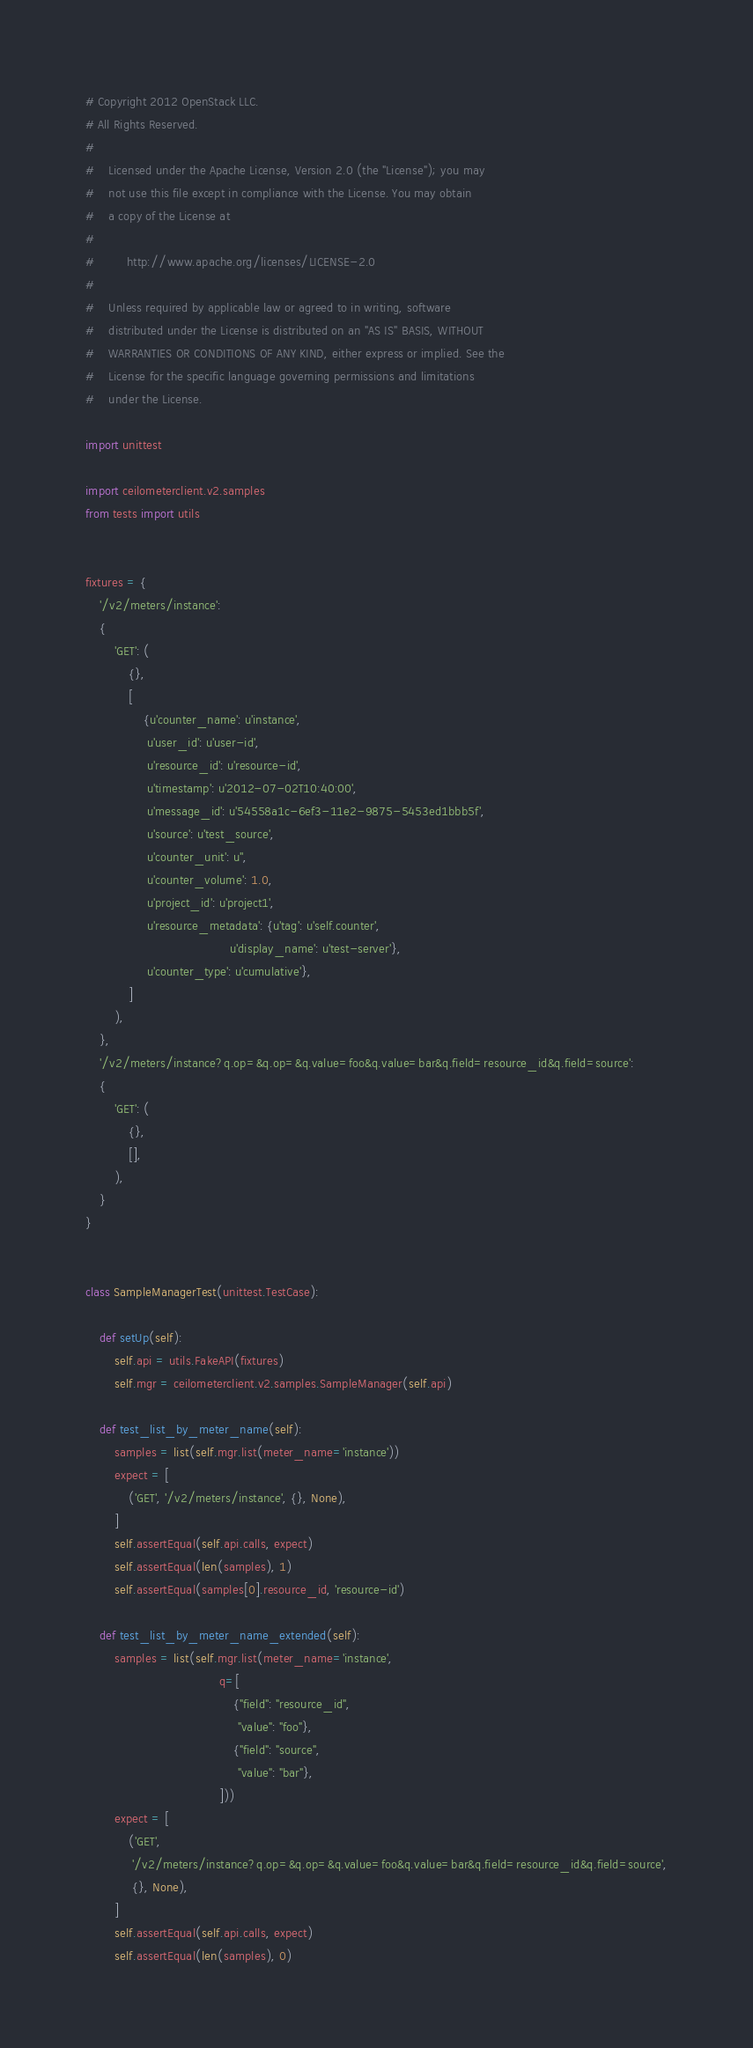Convert code to text. <code><loc_0><loc_0><loc_500><loc_500><_Python_># Copyright 2012 OpenStack LLC.
# All Rights Reserved.
#
#    Licensed under the Apache License, Version 2.0 (the "License"); you may
#    not use this file except in compliance with the License. You may obtain
#    a copy of the License at
#
#         http://www.apache.org/licenses/LICENSE-2.0
#
#    Unless required by applicable law or agreed to in writing, software
#    distributed under the License is distributed on an "AS IS" BASIS, WITHOUT
#    WARRANTIES OR CONDITIONS OF ANY KIND, either express or implied. See the
#    License for the specific language governing permissions and limitations
#    under the License.

import unittest

import ceilometerclient.v2.samples
from tests import utils


fixtures = {
    '/v2/meters/instance':
    {
        'GET': (
            {},
            [
                {u'counter_name': u'instance',
                 u'user_id': u'user-id',
                 u'resource_id': u'resource-id',
                 u'timestamp': u'2012-07-02T10:40:00',
                 u'message_id': u'54558a1c-6ef3-11e2-9875-5453ed1bbb5f',
                 u'source': u'test_source',
                 u'counter_unit': u'',
                 u'counter_volume': 1.0,
                 u'project_id': u'project1',
                 u'resource_metadata': {u'tag': u'self.counter',
                                        u'display_name': u'test-server'},
                 u'counter_type': u'cumulative'},
            ]
        ),
    },
    '/v2/meters/instance?q.op=&q.op=&q.value=foo&q.value=bar&q.field=resource_id&q.field=source':
    {
        'GET': (
            {},
            [],
        ),
    }
}


class SampleManagerTest(unittest.TestCase):

    def setUp(self):
        self.api = utils.FakeAPI(fixtures)
        self.mgr = ceilometerclient.v2.samples.SampleManager(self.api)

    def test_list_by_meter_name(self):
        samples = list(self.mgr.list(meter_name='instance'))
        expect = [
            ('GET', '/v2/meters/instance', {}, None),
        ]
        self.assertEqual(self.api.calls, expect)
        self.assertEqual(len(samples), 1)
        self.assertEqual(samples[0].resource_id, 'resource-id')

    def test_list_by_meter_name_extended(self):
        samples = list(self.mgr.list(meter_name='instance',
                                     q=[
                                         {"field": "resource_id",
                                          "value": "foo"},
                                         {"field": "source",
                                          "value": "bar"},
                                     ]))
        expect = [
            ('GET',
             '/v2/meters/instance?q.op=&q.op=&q.value=foo&q.value=bar&q.field=resource_id&q.field=source',
             {}, None),
        ]
        self.assertEqual(self.api.calls, expect)
        self.assertEqual(len(samples), 0)
</code> 